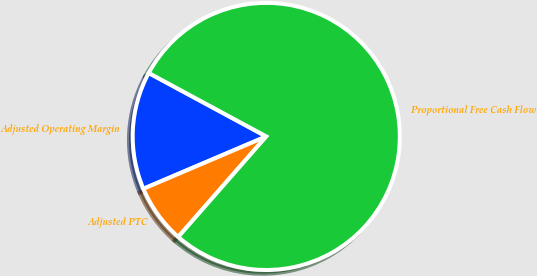<chart> <loc_0><loc_0><loc_500><loc_500><pie_chart><fcel>Adjusted Operating Margin<fcel>Adjusted PTC<fcel>Proportional Free Cash Flow<nl><fcel>14.29%<fcel>7.14%<fcel>78.57%<nl></chart> 